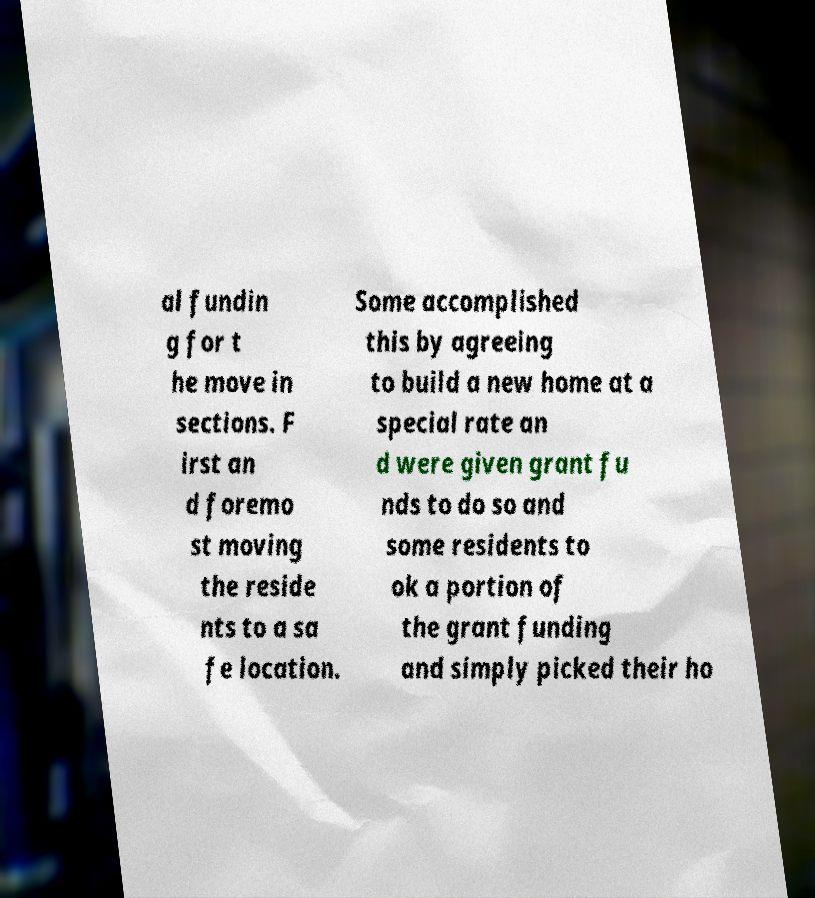Can you read and provide the text displayed in the image?This photo seems to have some interesting text. Can you extract and type it out for me? al fundin g for t he move in sections. F irst an d foremo st moving the reside nts to a sa fe location. Some accomplished this by agreeing to build a new home at a special rate an d were given grant fu nds to do so and some residents to ok a portion of the grant funding and simply picked their ho 